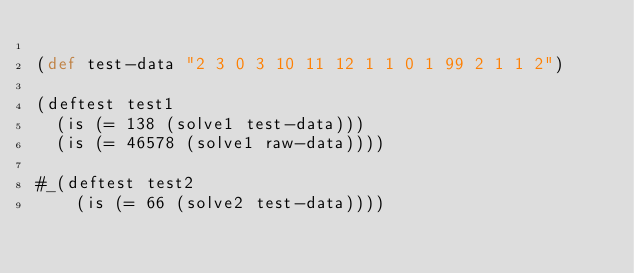Convert code to text. <code><loc_0><loc_0><loc_500><loc_500><_Clojure_>
(def test-data "2 3 0 3 10 11 12 1 1 0 1 99 2 1 1 2")

(deftest test1
  (is (= 138 (solve1 test-data)))
  (is (= 46578 (solve1 raw-data))))

#_(deftest test2
    (is (= 66 (solve2 test-data))))
</code> 